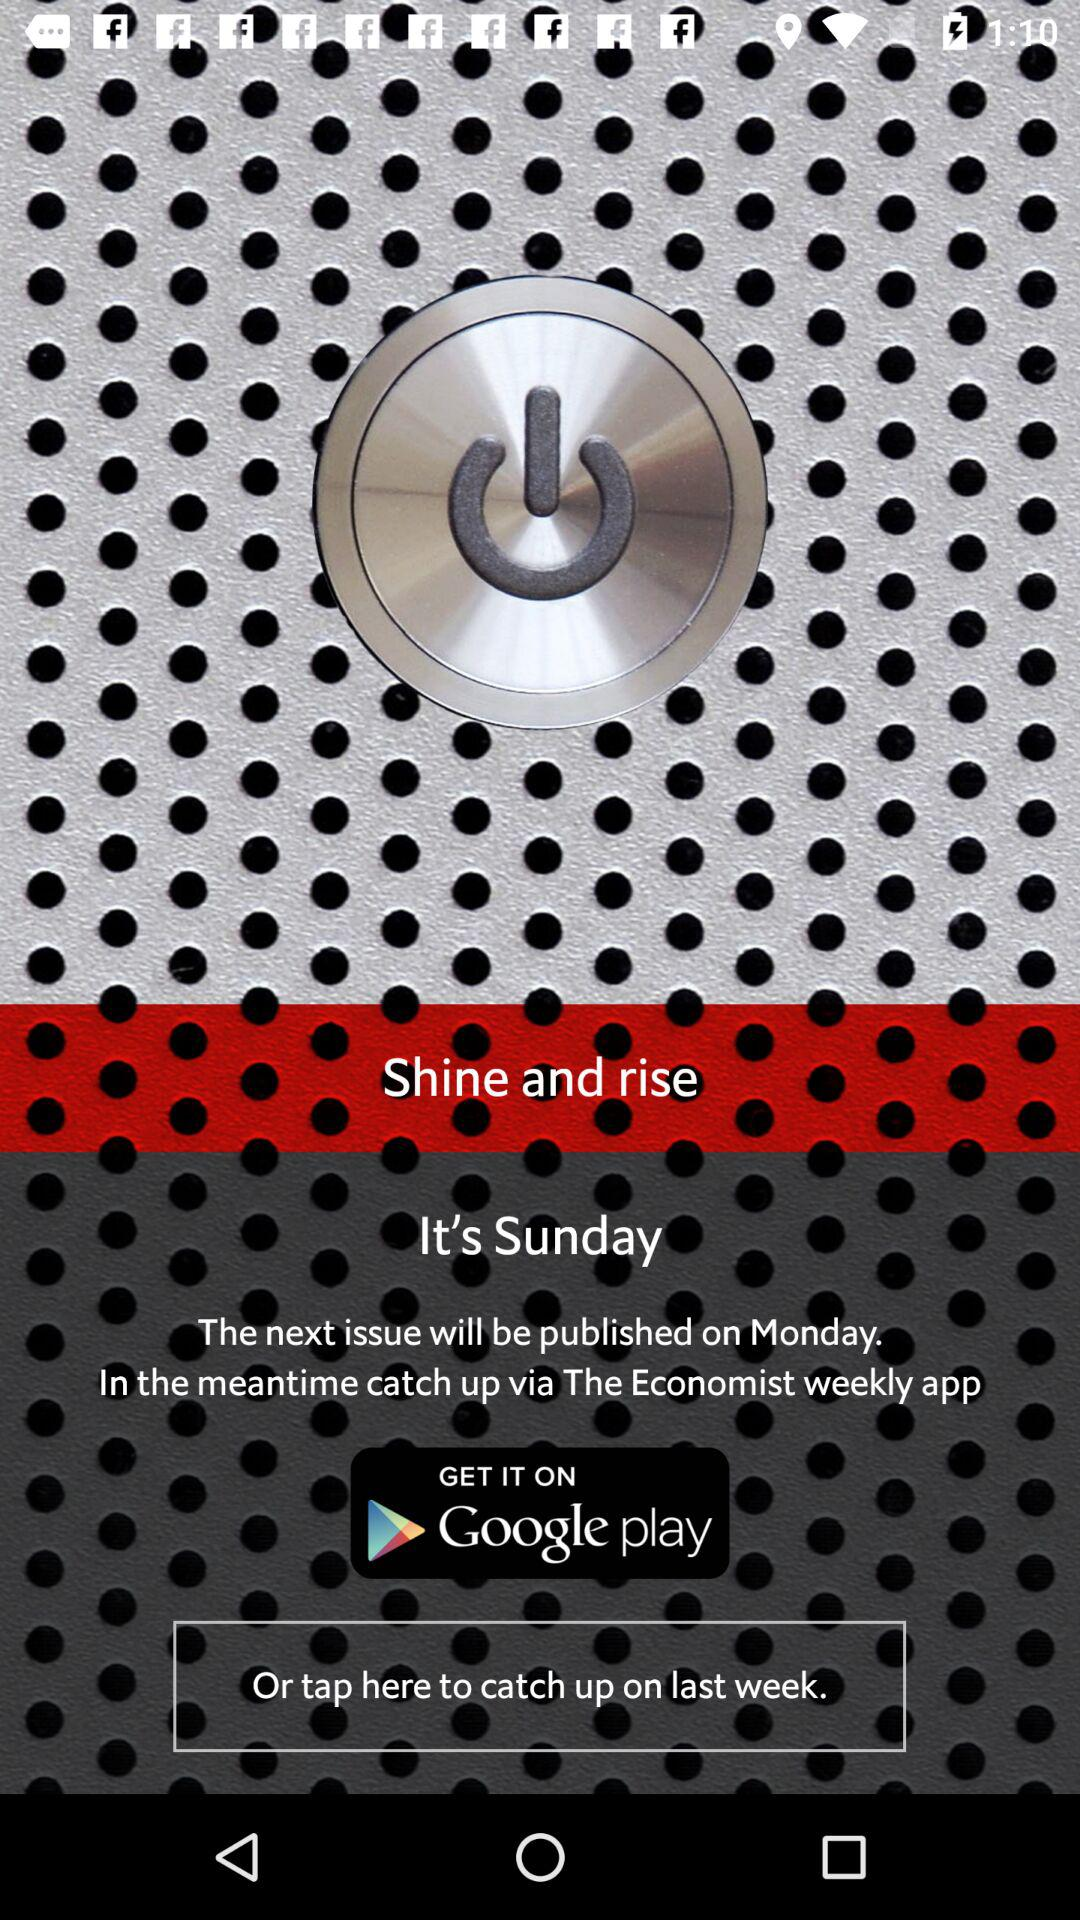What is the day today? The day is Sunday. 